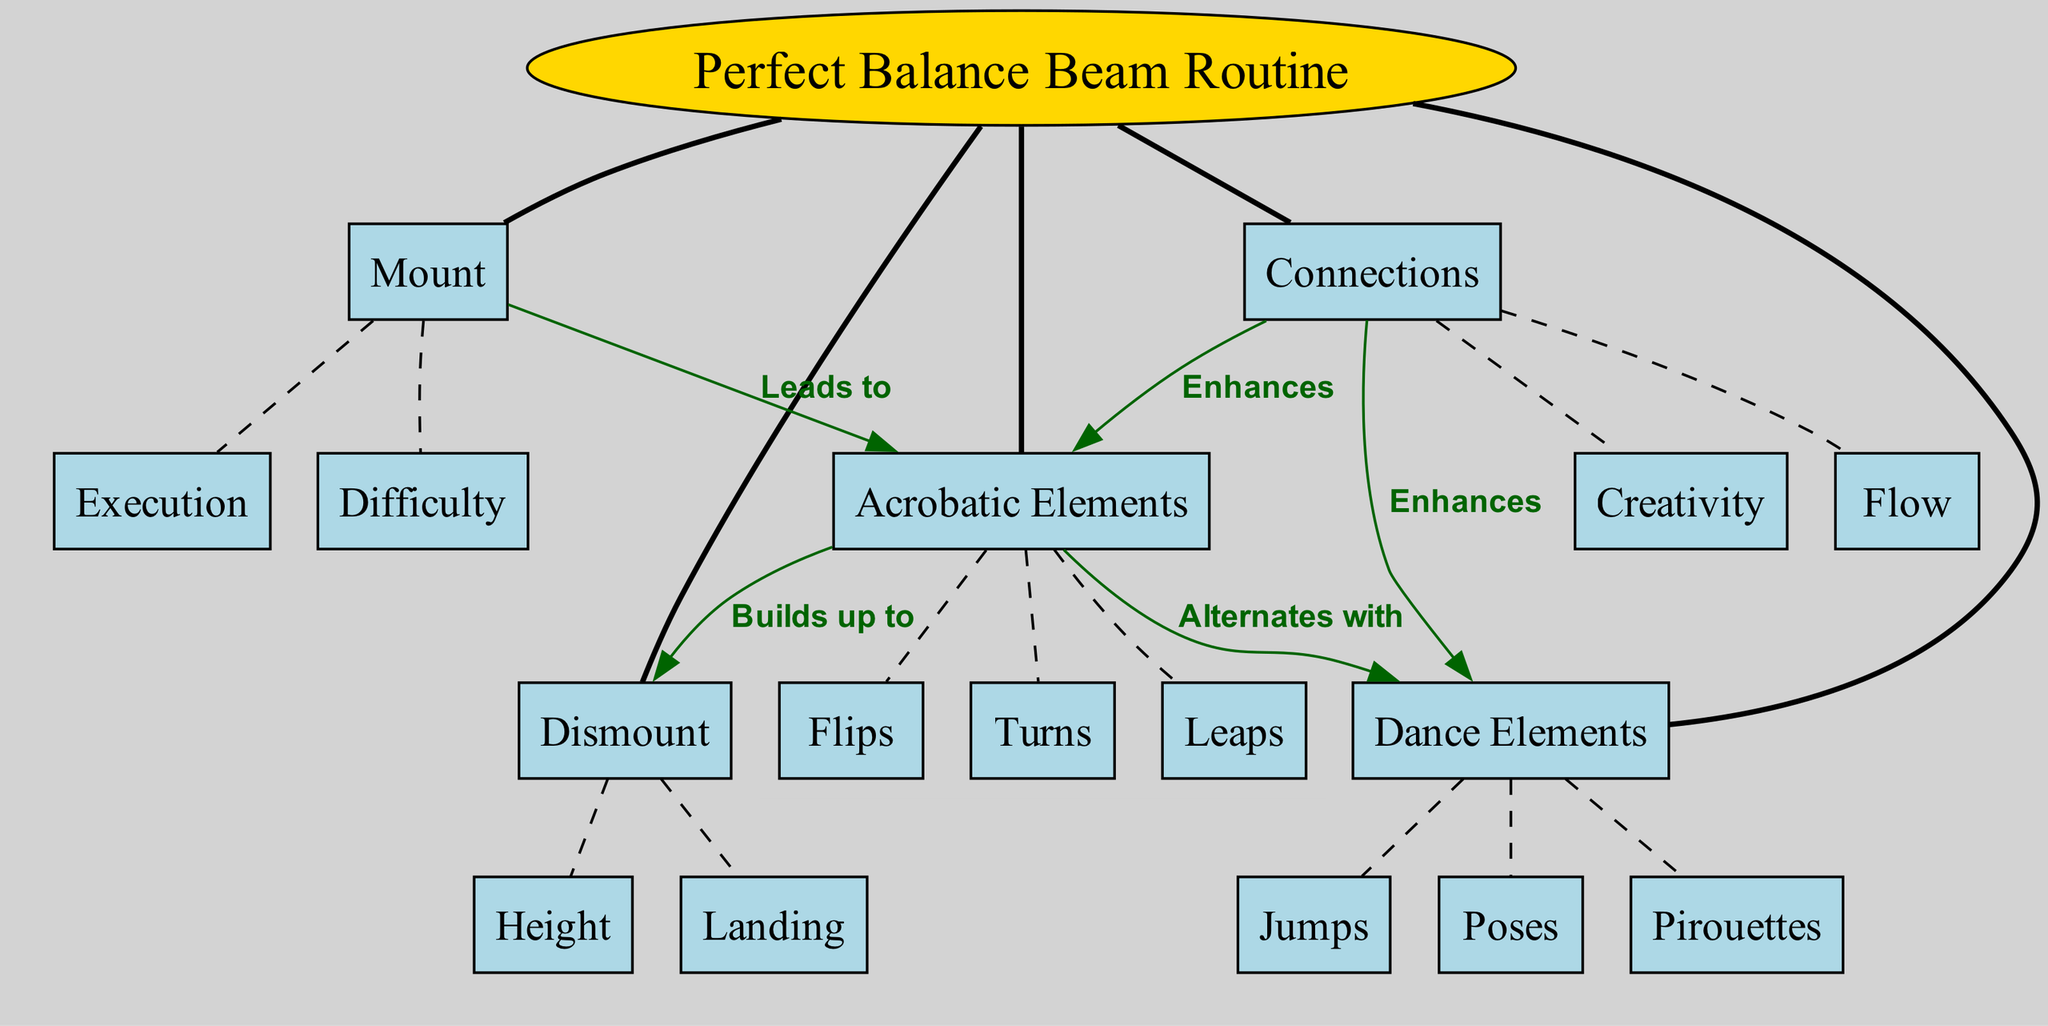What is the central concept of the diagram? The central concept is highlighted at the top of the diagram, labeled as "Perfect Balance Beam Routine."
Answer: Perfect Balance Beam Routine How many main elements are there in the diagram? The diagram displays five main elements branching out from the central concept, which are clearly labeled.
Answer: Five Which two elements are connected by "Alternates with"? The "Acrobatic Elements" and "Dance Elements" are specifically labeled with the relationship "Alternates with" in the diagram.
Answer: Acrobatic Elements and Dance Elements What are the sub-elements under "Mount"? Under the "Mount" element, there are two sub-elements: "Difficulty" and "Execution," as indicated in the diagram.
Answer: Difficulty, Execution Which main element enhances "Dance Elements"? The "Connections" main element is shown to enhance the "Dance Elements," as indicated by the directed edge labeled "Enhances."
Answer: Connections What builds up to the "Dismount"? "Acrobatic Elements" directly build up to the "Dismount," which is described by the labeled connection in the diagram.
Answer: Acrobatic Elements What is the relationship between "Connections" and "Acrobatic Elements"? The diagram indicates that "Connections" enhances "Acrobatic Elements," showing a directional relationship labeled "Enhances."
Answer: Enhances Which sub-element is part of the "Dance Elements"? The sub-elements listed under "Dance Elements" include "Pirouettes," "Jumps," and "Poses," any of which could be an acceptable answer.
Answer: Pirouettes How does "Acrobatic Elements" relate to "Dismount"? The relationship is defined by the label "Builds up to," indicating that "Acrobatic Elements" lead towards the performance of the "Dismount."
Answer: Builds up to 